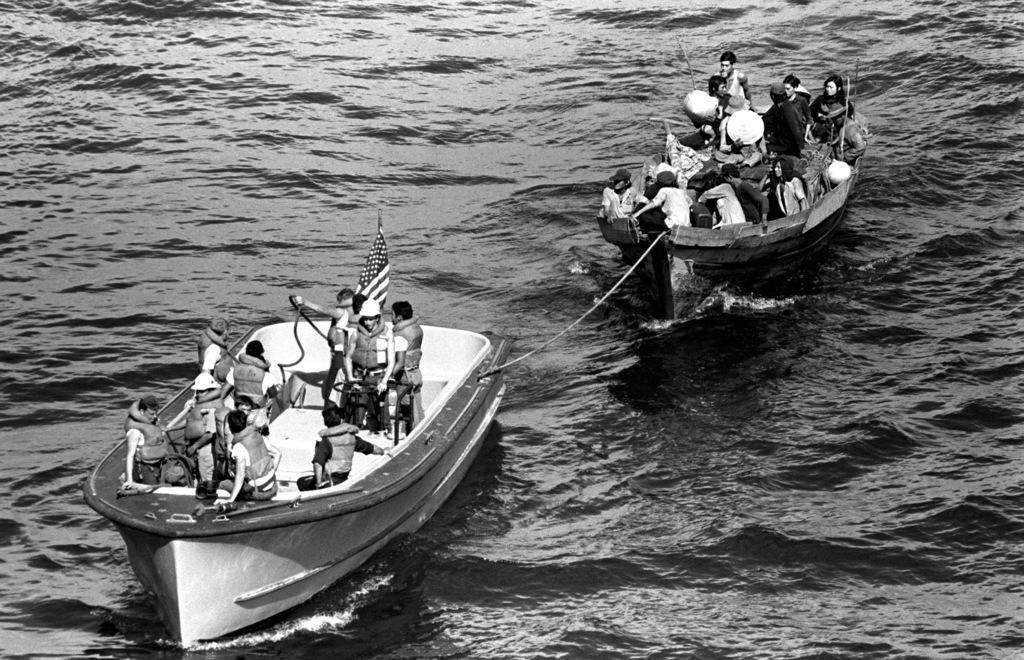Can you describe this image briefly? It is a black and white image. In this image, we can see people are sailing boats on the water. Here we can see a flag. 